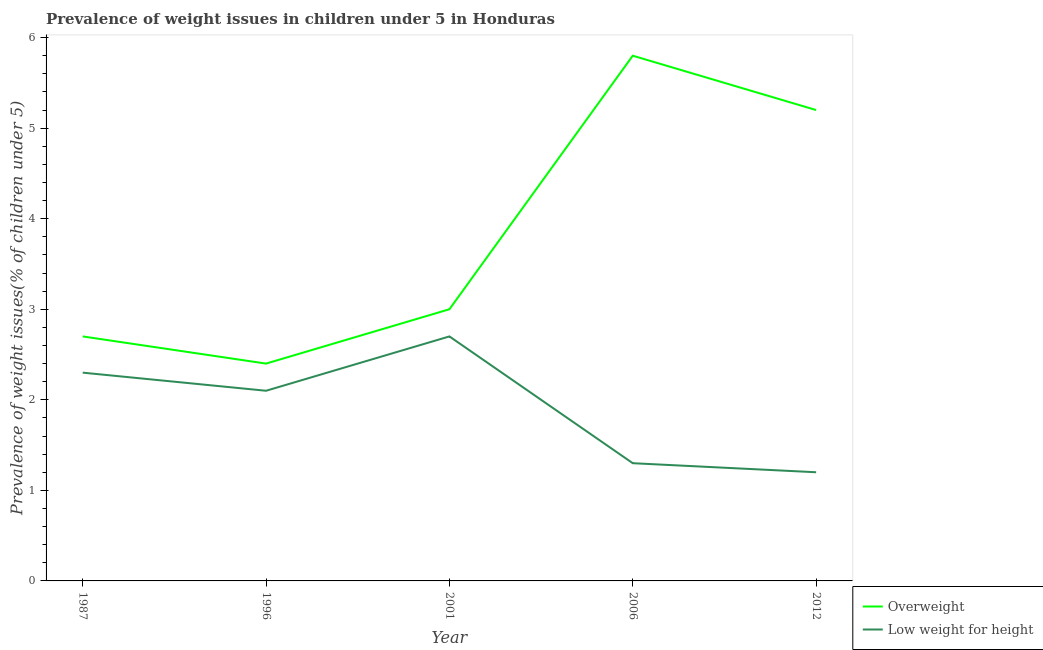What is the percentage of underweight children in 2012?
Your answer should be compact. 1.2. Across all years, what is the maximum percentage of underweight children?
Offer a terse response. 2.7. Across all years, what is the minimum percentage of overweight children?
Provide a short and direct response. 2.4. In which year was the percentage of overweight children maximum?
Your response must be concise. 2006. What is the total percentage of overweight children in the graph?
Your response must be concise. 19.1. What is the difference between the percentage of overweight children in 2001 and that in 2006?
Keep it short and to the point. -2.8. What is the difference between the percentage of overweight children in 1987 and the percentage of underweight children in 1996?
Provide a succinct answer. 0.6. What is the average percentage of overweight children per year?
Provide a short and direct response. 3.82. In the year 2012, what is the difference between the percentage of underweight children and percentage of overweight children?
Offer a terse response. -4. What is the ratio of the percentage of underweight children in 2001 to that in 2012?
Make the answer very short. 2.25. Is the percentage of underweight children in 1996 less than that in 2012?
Your response must be concise. No. Is the difference between the percentage of overweight children in 1996 and 2012 greater than the difference between the percentage of underweight children in 1996 and 2012?
Offer a very short reply. No. What is the difference between the highest and the second highest percentage of underweight children?
Your response must be concise. 0.4. What is the difference between the highest and the lowest percentage of overweight children?
Ensure brevity in your answer.  3.4. In how many years, is the percentage of underweight children greater than the average percentage of underweight children taken over all years?
Your answer should be compact. 3. Is the sum of the percentage of overweight children in 2001 and 2012 greater than the maximum percentage of underweight children across all years?
Keep it short and to the point. Yes. Does the percentage of underweight children monotonically increase over the years?
Ensure brevity in your answer.  No. Is the percentage of overweight children strictly greater than the percentage of underweight children over the years?
Keep it short and to the point. Yes. What is the difference between two consecutive major ticks on the Y-axis?
Make the answer very short. 1. Does the graph contain any zero values?
Your response must be concise. No. Where does the legend appear in the graph?
Provide a succinct answer. Bottom right. How are the legend labels stacked?
Offer a very short reply. Vertical. What is the title of the graph?
Provide a short and direct response. Prevalence of weight issues in children under 5 in Honduras. Does "Money lenders" appear as one of the legend labels in the graph?
Offer a very short reply. No. What is the label or title of the Y-axis?
Your response must be concise. Prevalence of weight issues(% of children under 5). What is the Prevalence of weight issues(% of children under 5) in Overweight in 1987?
Keep it short and to the point. 2.7. What is the Prevalence of weight issues(% of children under 5) in Low weight for height in 1987?
Give a very brief answer. 2.3. What is the Prevalence of weight issues(% of children under 5) of Overweight in 1996?
Offer a very short reply. 2.4. What is the Prevalence of weight issues(% of children under 5) in Low weight for height in 1996?
Give a very brief answer. 2.1. What is the Prevalence of weight issues(% of children under 5) in Low weight for height in 2001?
Ensure brevity in your answer.  2.7. What is the Prevalence of weight issues(% of children under 5) in Overweight in 2006?
Offer a terse response. 5.8. What is the Prevalence of weight issues(% of children under 5) in Low weight for height in 2006?
Your answer should be very brief. 1.3. What is the Prevalence of weight issues(% of children under 5) in Overweight in 2012?
Your answer should be compact. 5.2. What is the Prevalence of weight issues(% of children under 5) of Low weight for height in 2012?
Provide a succinct answer. 1.2. Across all years, what is the maximum Prevalence of weight issues(% of children under 5) in Overweight?
Provide a short and direct response. 5.8. Across all years, what is the maximum Prevalence of weight issues(% of children under 5) of Low weight for height?
Provide a short and direct response. 2.7. Across all years, what is the minimum Prevalence of weight issues(% of children under 5) of Overweight?
Ensure brevity in your answer.  2.4. Across all years, what is the minimum Prevalence of weight issues(% of children under 5) in Low weight for height?
Your answer should be very brief. 1.2. What is the total Prevalence of weight issues(% of children under 5) in Low weight for height in the graph?
Your answer should be compact. 9.6. What is the difference between the Prevalence of weight issues(% of children under 5) in Overweight in 1987 and that in 2001?
Offer a very short reply. -0.3. What is the difference between the Prevalence of weight issues(% of children under 5) of Overweight in 1987 and that in 2006?
Your response must be concise. -3.1. What is the difference between the Prevalence of weight issues(% of children under 5) of Low weight for height in 1987 and that in 2006?
Provide a short and direct response. 1. What is the difference between the Prevalence of weight issues(% of children under 5) in Low weight for height in 1987 and that in 2012?
Make the answer very short. 1.1. What is the difference between the Prevalence of weight issues(% of children under 5) in Overweight in 1996 and that in 2001?
Offer a terse response. -0.6. What is the difference between the Prevalence of weight issues(% of children under 5) in Overweight in 1996 and that in 2006?
Make the answer very short. -3.4. What is the difference between the Prevalence of weight issues(% of children under 5) of Low weight for height in 1996 and that in 2012?
Give a very brief answer. 0.9. What is the difference between the Prevalence of weight issues(% of children under 5) of Overweight in 2001 and that in 2006?
Provide a short and direct response. -2.8. What is the difference between the Prevalence of weight issues(% of children under 5) of Low weight for height in 2001 and that in 2012?
Your response must be concise. 1.5. What is the difference between the Prevalence of weight issues(% of children under 5) of Overweight in 1987 and the Prevalence of weight issues(% of children under 5) of Low weight for height in 1996?
Your answer should be compact. 0.6. What is the difference between the Prevalence of weight issues(% of children under 5) of Overweight in 1987 and the Prevalence of weight issues(% of children under 5) of Low weight for height in 2006?
Offer a very short reply. 1.4. What is the difference between the Prevalence of weight issues(% of children under 5) of Overweight in 1987 and the Prevalence of weight issues(% of children under 5) of Low weight for height in 2012?
Provide a succinct answer. 1.5. What is the difference between the Prevalence of weight issues(% of children under 5) of Overweight in 1996 and the Prevalence of weight issues(% of children under 5) of Low weight for height in 2006?
Offer a very short reply. 1.1. What is the difference between the Prevalence of weight issues(% of children under 5) of Overweight in 1996 and the Prevalence of weight issues(% of children under 5) of Low weight for height in 2012?
Ensure brevity in your answer.  1.2. What is the difference between the Prevalence of weight issues(% of children under 5) in Overweight in 2001 and the Prevalence of weight issues(% of children under 5) in Low weight for height in 2006?
Ensure brevity in your answer.  1.7. What is the difference between the Prevalence of weight issues(% of children under 5) in Overweight in 2001 and the Prevalence of weight issues(% of children under 5) in Low weight for height in 2012?
Provide a succinct answer. 1.8. What is the average Prevalence of weight issues(% of children under 5) in Overweight per year?
Offer a terse response. 3.82. What is the average Prevalence of weight issues(% of children under 5) of Low weight for height per year?
Your response must be concise. 1.92. In the year 1987, what is the difference between the Prevalence of weight issues(% of children under 5) of Overweight and Prevalence of weight issues(% of children under 5) of Low weight for height?
Your answer should be very brief. 0.4. In the year 1996, what is the difference between the Prevalence of weight issues(% of children under 5) in Overweight and Prevalence of weight issues(% of children under 5) in Low weight for height?
Provide a short and direct response. 0.3. In the year 2001, what is the difference between the Prevalence of weight issues(% of children under 5) of Overweight and Prevalence of weight issues(% of children under 5) of Low weight for height?
Offer a very short reply. 0.3. In the year 2006, what is the difference between the Prevalence of weight issues(% of children under 5) of Overweight and Prevalence of weight issues(% of children under 5) of Low weight for height?
Provide a succinct answer. 4.5. In the year 2012, what is the difference between the Prevalence of weight issues(% of children under 5) of Overweight and Prevalence of weight issues(% of children under 5) of Low weight for height?
Your answer should be compact. 4. What is the ratio of the Prevalence of weight issues(% of children under 5) in Low weight for height in 1987 to that in 1996?
Provide a short and direct response. 1.1. What is the ratio of the Prevalence of weight issues(% of children under 5) in Overweight in 1987 to that in 2001?
Provide a succinct answer. 0.9. What is the ratio of the Prevalence of weight issues(% of children under 5) of Low weight for height in 1987 to that in 2001?
Give a very brief answer. 0.85. What is the ratio of the Prevalence of weight issues(% of children under 5) in Overweight in 1987 to that in 2006?
Offer a terse response. 0.47. What is the ratio of the Prevalence of weight issues(% of children under 5) of Low weight for height in 1987 to that in 2006?
Keep it short and to the point. 1.77. What is the ratio of the Prevalence of weight issues(% of children under 5) of Overweight in 1987 to that in 2012?
Your answer should be very brief. 0.52. What is the ratio of the Prevalence of weight issues(% of children under 5) in Low weight for height in 1987 to that in 2012?
Offer a very short reply. 1.92. What is the ratio of the Prevalence of weight issues(% of children under 5) of Overweight in 1996 to that in 2001?
Provide a succinct answer. 0.8. What is the ratio of the Prevalence of weight issues(% of children under 5) of Overweight in 1996 to that in 2006?
Give a very brief answer. 0.41. What is the ratio of the Prevalence of weight issues(% of children under 5) of Low weight for height in 1996 to that in 2006?
Your answer should be compact. 1.62. What is the ratio of the Prevalence of weight issues(% of children under 5) of Overweight in 1996 to that in 2012?
Your response must be concise. 0.46. What is the ratio of the Prevalence of weight issues(% of children under 5) in Low weight for height in 1996 to that in 2012?
Provide a short and direct response. 1.75. What is the ratio of the Prevalence of weight issues(% of children under 5) of Overweight in 2001 to that in 2006?
Provide a succinct answer. 0.52. What is the ratio of the Prevalence of weight issues(% of children under 5) of Low weight for height in 2001 to that in 2006?
Ensure brevity in your answer.  2.08. What is the ratio of the Prevalence of weight issues(% of children under 5) in Overweight in 2001 to that in 2012?
Offer a terse response. 0.58. What is the ratio of the Prevalence of weight issues(% of children under 5) in Low weight for height in 2001 to that in 2012?
Offer a terse response. 2.25. What is the ratio of the Prevalence of weight issues(% of children under 5) in Overweight in 2006 to that in 2012?
Offer a terse response. 1.12. What is the ratio of the Prevalence of weight issues(% of children under 5) of Low weight for height in 2006 to that in 2012?
Provide a short and direct response. 1.08. What is the difference between the highest and the second highest Prevalence of weight issues(% of children under 5) of Overweight?
Ensure brevity in your answer.  0.6. What is the difference between the highest and the second highest Prevalence of weight issues(% of children under 5) of Low weight for height?
Give a very brief answer. 0.4. 